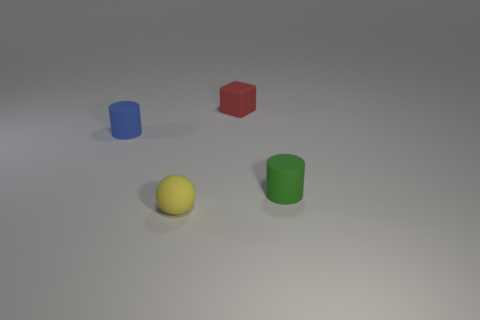What can you infer about the texture of the objects and the surface? The objects appear to have a smooth texture, with a matte finish that diffusely reflects the light source. The surface on which they are placed also looks smooth, but with a slight roughness that is noticeable due to the gentle shadows and light distribution, suggesting it may feel less sleek than the objects themselves. 